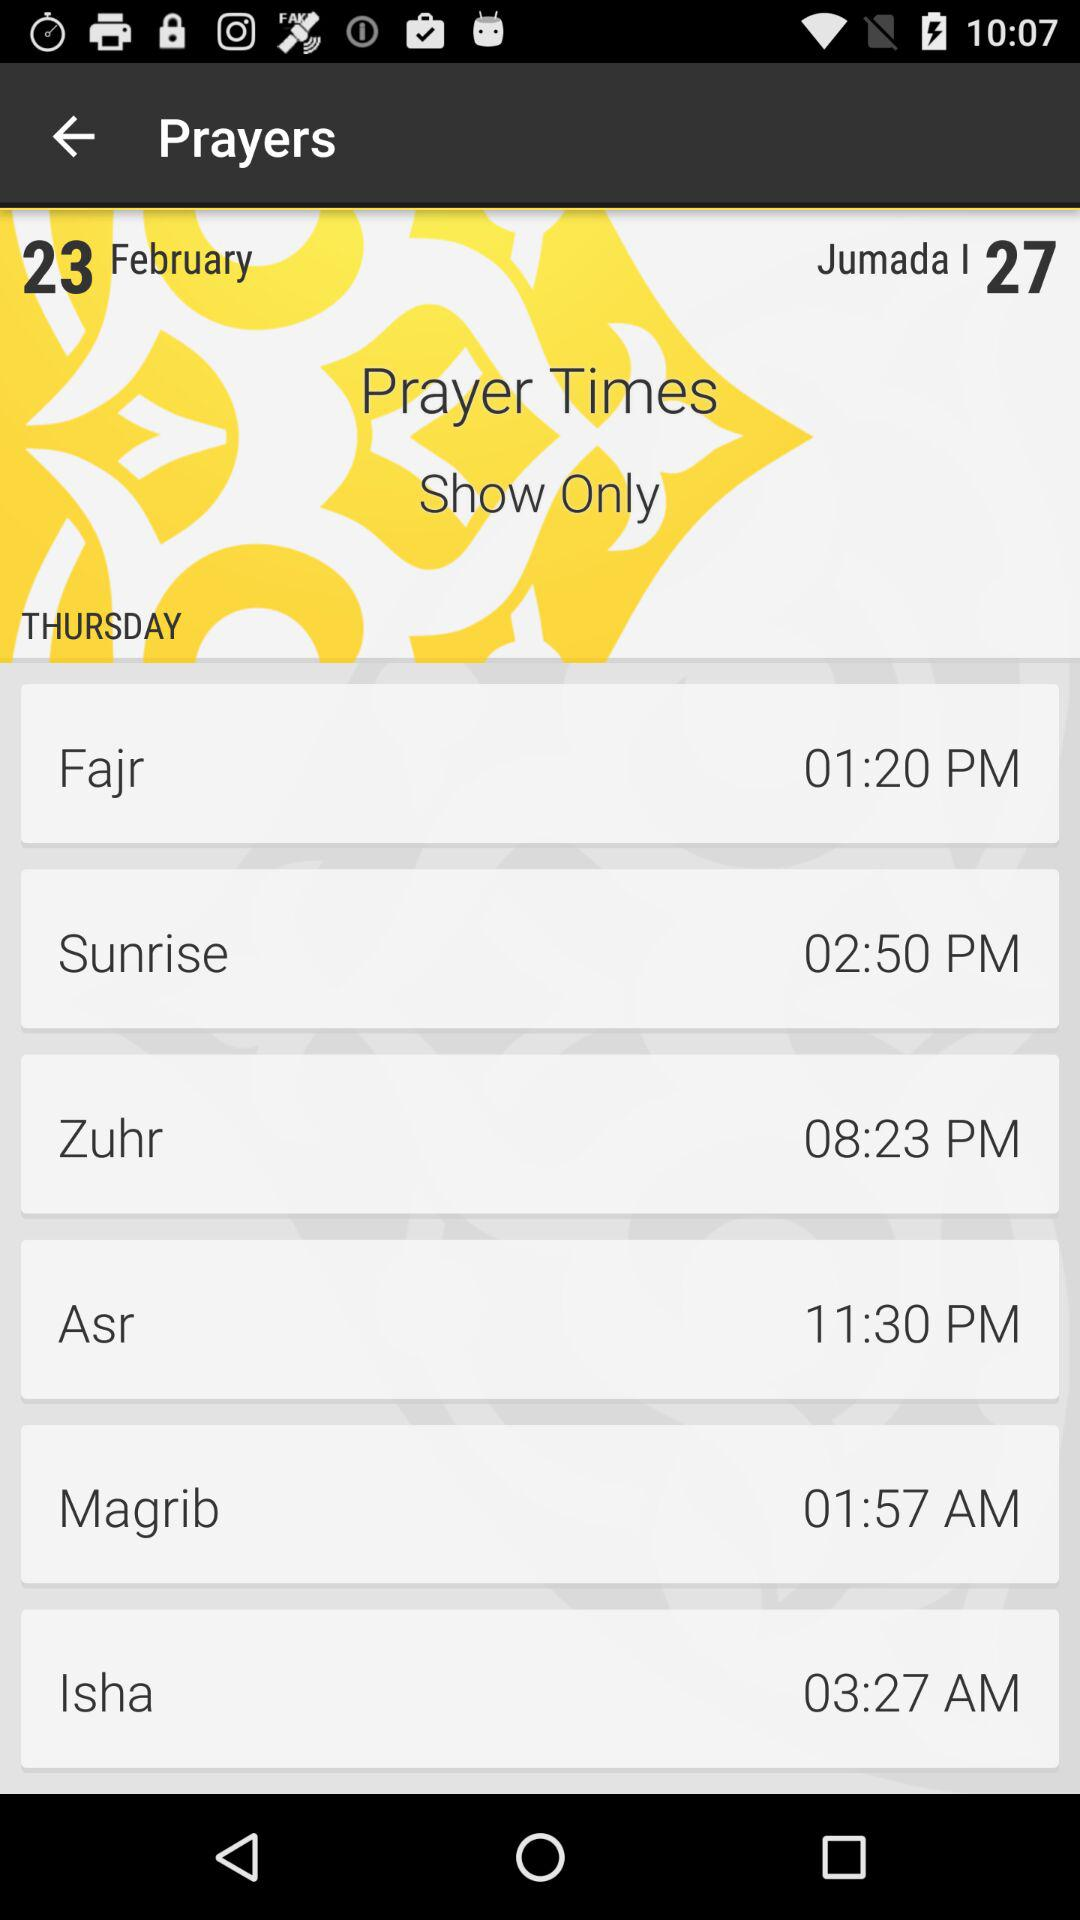Which prayer time is 1:20 PM? The prayer is "Fajr". 